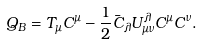Convert formula to latex. <formula><loc_0><loc_0><loc_500><loc_500>Q _ { B } = T _ { \mu } C ^ { \mu } - \frac { 1 } { 2 } \bar { C } _ { \lambda } U _ { \mu \nu } ^ { \lambda } C ^ { \mu } C ^ { \nu } .</formula> 